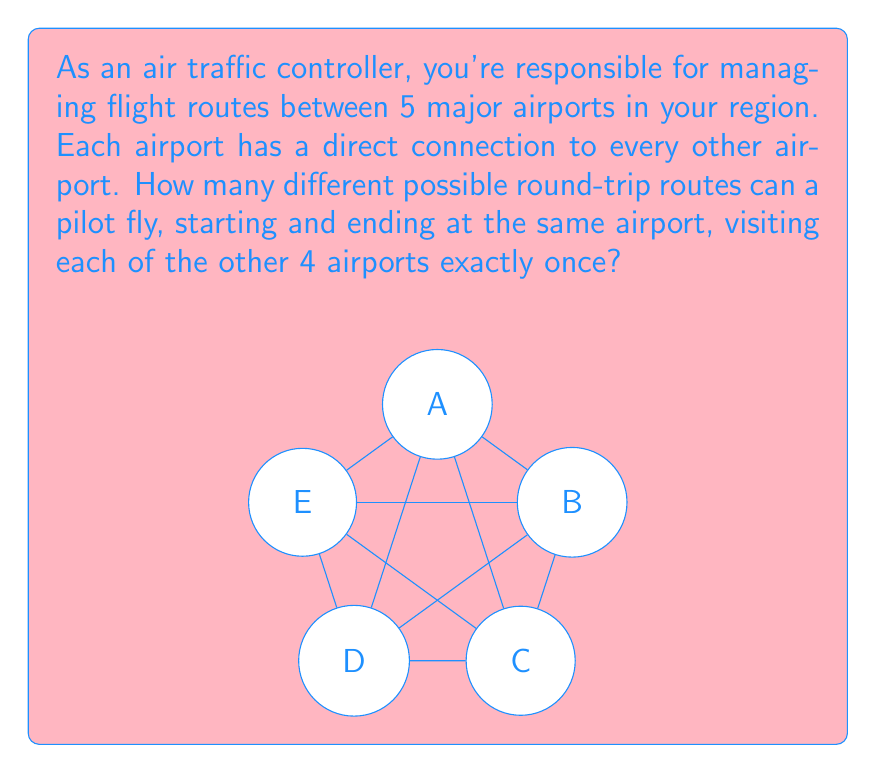Provide a solution to this math problem. Let's approach this step-by-step:

1) First, we need to understand what the question is asking. We're looking for round-trip routes that:
   - Start and end at the same airport
   - Visit each of the other 4 airports exactly once

2) This is a permutation problem. We need to arrange 4 airports in a sequence, and then return to the starting airport.

3) The number of ways to arrange 4 airports is given by the permutation formula:

   $$P(4,4) = 4! = 4 \times 3 \times 2 \times 1 = 24$$

4) However, this counts each unique route multiple times because we can start at any of the 5 airports. We need to divide by 5 to account for this:

   $$\text{Number of routes} = \frac{4!}{5} = \frac{24}{5} = 4.8$$

5) But wait! We can't have a fractional number of routes. This is because we've overlooked something important in our calculation.

6) In fact, for each arrangement of 4 airports, we can traverse it in two directions: clockwise and counterclockwise. So we need to multiply our result by 2:

   $$\text{Number of routes} = 2 \times \frac{4!}{5} = 2 \times 4.8 = 9.6 = 12$$

Therefore, there are 12 possible round-trip routes that satisfy the given conditions.
Answer: 12 routes 